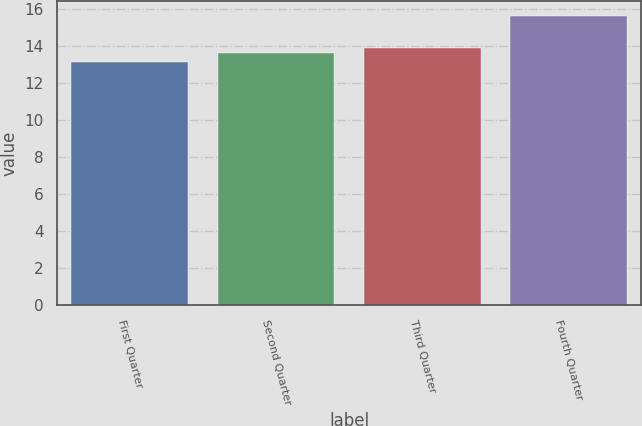<chart> <loc_0><loc_0><loc_500><loc_500><bar_chart><fcel>First Quarter<fcel>Second Quarter<fcel>Third Quarter<fcel>Fourth Quarter<nl><fcel>13.15<fcel>13.64<fcel>13.89<fcel>15.63<nl></chart> 